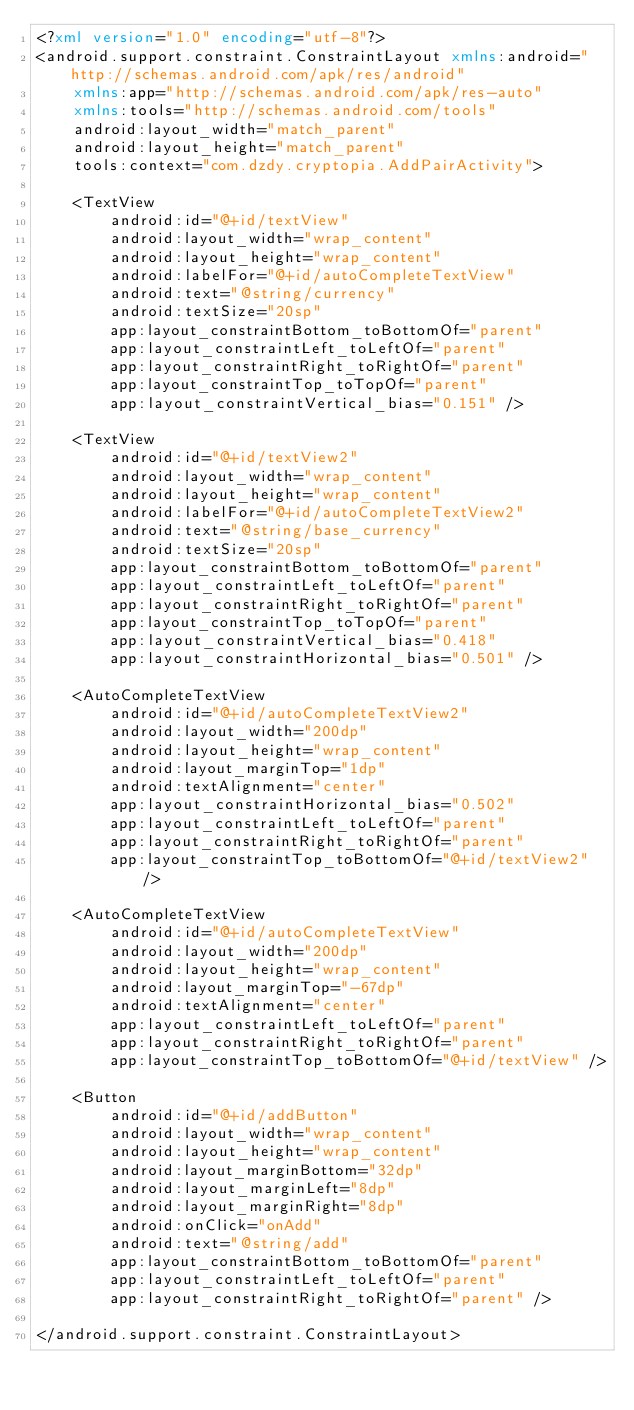<code> <loc_0><loc_0><loc_500><loc_500><_XML_><?xml version="1.0" encoding="utf-8"?>
<android.support.constraint.ConstraintLayout xmlns:android="http://schemas.android.com/apk/res/android"
    xmlns:app="http://schemas.android.com/apk/res-auto"
    xmlns:tools="http://schemas.android.com/tools"
    android:layout_width="match_parent"
    android:layout_height="match_parent"
    tools:context="com.dzdy.cryptopia.AddPairActivity">

    <TextView
        android:id="@+id/textView"
        android:layout_width="wrap_content"
        android:layout_height="wrap_content"
        android:labelFor="@+id/autoCompleteTextView"
        android:text="@string/currency"
        android:textSize="20sp"
        app:layout_constraintBottom_toBottomOf="parent"
        app:layout_constraintLeft_toLeftOf="parent"
        app:layout_constraintRight_toRightOf="parent"
        app:layout_constraintTop_toTopOf="parent"
        app:layout_constraintVertical_bias="0.151" />

    <TextView
        android:id="@+id/textView2"
        android:layout_width="wrap_content"
        android:layout_height="wrap_content"
        android:labelFor="@+id/autoCompleteTextView2"
        android:text="@string/base_currency"
        android:textSize="20sp"
        app:layout_constraintBottom_toBottomOf="parent"
        app:layout_constraintLeft_toLeftOf="parent"
        app:layout_constraintRight_toRightOf="parent"
        app:layout_constraintTop_toTopOf="parent"
        app:layout_constraintVertical_bias="0.418"
        app:layout_constraintHorizontal_bias="0.501" />

    <AutoCompleteTextView
        android:id="@+id/autoCompleteTextView2"
        android:layout_width="200dp"
        android:layout_height="wrap_content"
        android:layout_marginTop="1dp"
        android:textAlignment="center"
        app:layout_constraintHorizontal_bias="0.502"
        app:layout_constraintLeft_toLeftOf="parent"
        app:layout_constraintRight_toRightOf="parent"
        app:layout_constraintTop_toBottomOf="@+id/textView2" />

    <AutoCompleteTextView
        android:id="@+id/autoCompleteTextView"
        android:layout_width="200dp"
        android:layout_height="wrap_content"
        android:layout_marginTop="-67dp"
        android:textAlignment="center"
        app:layout_constraintLeft_toLeftOf="parent"
        app:layout_constraintRight_toRightOf="parent"
        app:layout_constraintTop_toBottomOf="@+id/textView" />

    <Button
        android:id="@+id/addButton"
        android:layout_width="wrap_content"
        android:layout_height="wrap_content"
        android:layout_marginBottom="32dp"
        android:layout_marginLeft="8dp"
        android:layout_marginRight="8dp"
        android:onClick="onAdd"
        android:text="@string/add"
        app:layout_constraintBottom_toBottomOf="parent"
        app:layout_constraintLeft_toLeftOf="parent"
        app:layout_constraintRight_toRightOf="parent" />

</android.support.constraint.ConstraintLayout>
</code> 